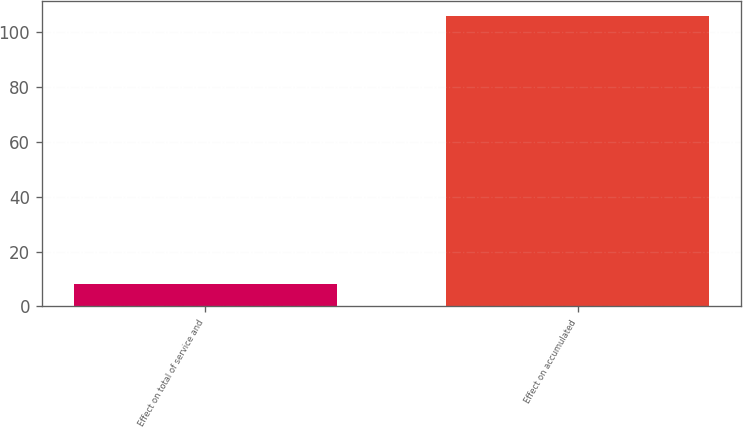<chart> <loc_0><loc_0><loc_500><loc_500><bar_chart><fcel>Effect on total of service and<fcel>Effect on accumulated<nl><fcel>8<fcel>106<nl></chart> 